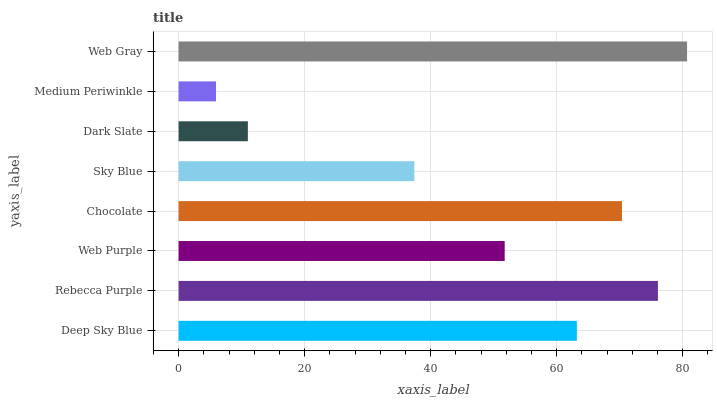Is Medium Periwinkle the minimum?
Answer yes or no. Yes. Is Web Gray the maximum?
Answer yes or no. Yes. Is Rebecca Purple the minimum?
Answer yes or no. No. Is Rebecca Purple the maximum?
Answer yes or no. No. Is Rebecca Purple greater than Deep Sky Blue?
Answer yes or no. Yes. Is Deep Sky Blue less than Rebecca Purple?
Answer yes or no. Yes. Is Deep Sky Blue greater than Rebecca Purple?
Answer yes or no. No. Is Rebecca Purple less than Deep Sky Blue?
Answer yes or no. No. Is Deep Sky Blue the high median?
Answer yes or no. Yes. Is Web Purple the low median?
Answer yes or no. Yes. Is Chocolate the high median?
Answer yes or no. No. Is Deep Sky Blue the low median?
Answer yes or no. No. 